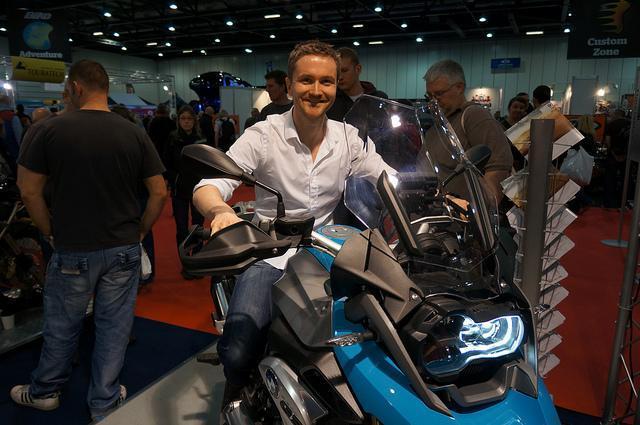How many motorcycles are in the picture?
Give a very brief answer. 2. How many people are in the photo?
Give a very brief answer. 4. 